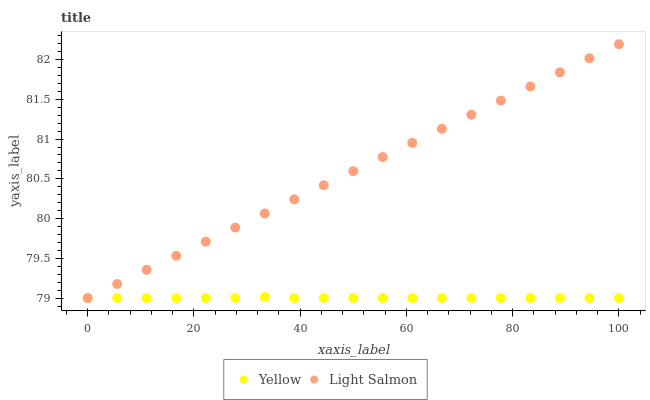Does Yellow have the minimum area under the curve?
Answer yes or no. Yes. Does Light Salmon have the maximum area under the curve?
Answer yes or no. Yes. Does Yellow have the maximum area under the curve?
Answer yes or no. No. Is Light Salmon the smoothest?
Answer yes or no. Yes. Is Yellow the roughest?
Answer yes or no. Yes. Is Yellow the smoothest?
Answer yes or no. No. Does Light Salmon have the lowest value?
Answer yes or no. Yes. Does Light Salmon have the highest value?
Answer yes or no. Yes. Does Yellow have the highest value?
Answer yes or no. No. Does Yellow intersect Light Salmon?
Answer yes or no. Yes. Is Yellow less than Light Salmon?
Answer yes or no. No. Is Yellow greater than Light Salmon?
Answer yes or no. No. 